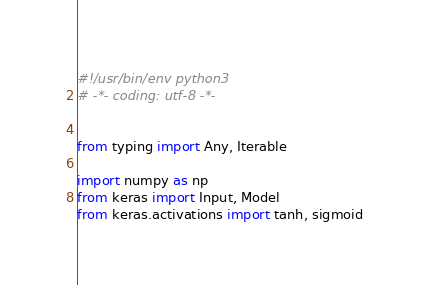Convert code to text. <code><loc_0><loc_0><loc_500><loc_500><_Python_>#!/usr/bin/env python3
# -*- coding: utf-8 -*-


from typing import Any, Iterable

import numpy as np
from keras import Input, Model
from keras.activations import tanh, sigmoid</code> 